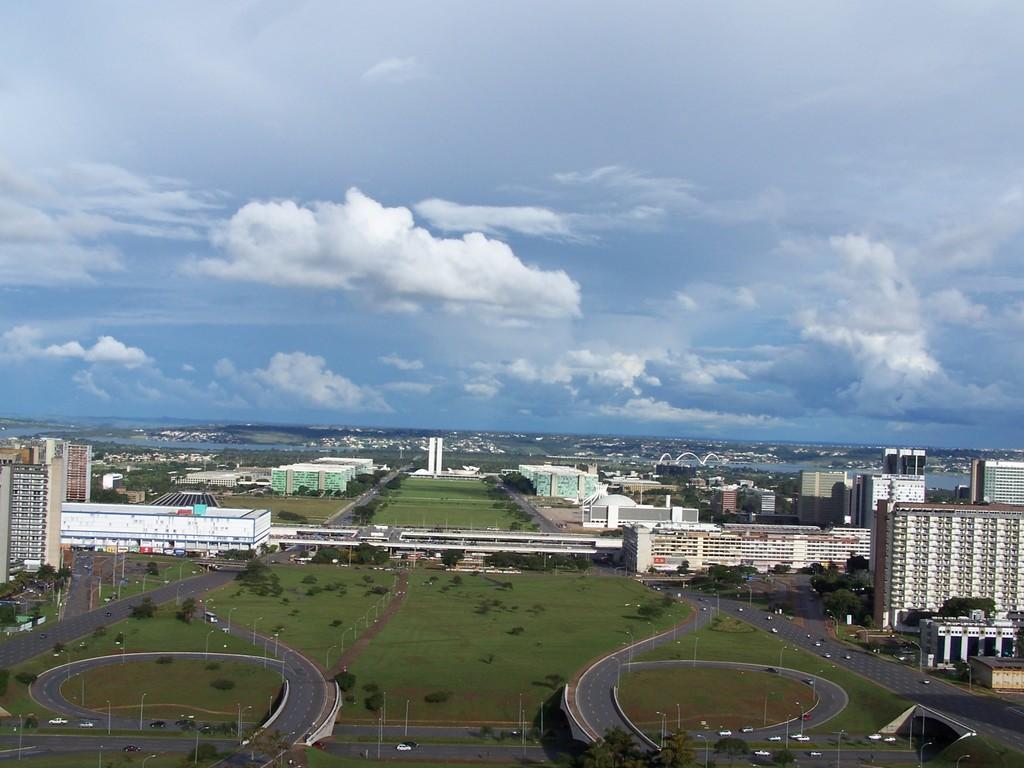Can you describe this image briefly? This image is clicked outside. It looks like it is clicked from a plane. In the front, there are many building along with grass and roads. At the top, there are clouds in the sky. 